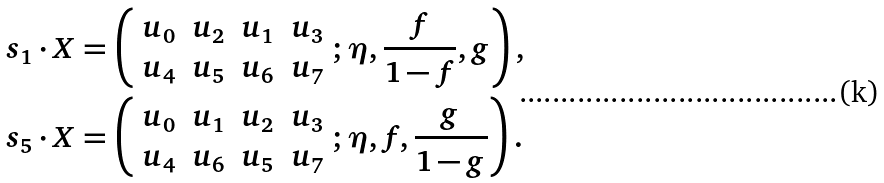<formula> <loc_0><loc_0><loc_500><loc_500>s _ { 1 } & \cdot X = \left ( \begin{array} { c c c c } u _ { 0 } & u _ { 2 } & u _ { 1 } & u _ { 3 } \\ u _ { 4 } & u _ { 5 } & u _ { 6 } & u _ { 7 } \end{array} ; \eta , \frac { f } { 1 - f } , g \right ) , \\ s _ { 5 } & \cdot X = \left ( \begin{array} { c c c c } u _ { 0 } & u _ { 1 } & u _ { 2 } & u _ { 3 } \\ u _ { 4 } & u _ { 6 } & u _ { 5 } & u _ { 7 } \end{array} ; \eta , f , \frac { g } { 1 - g } \right ) .</formula> 